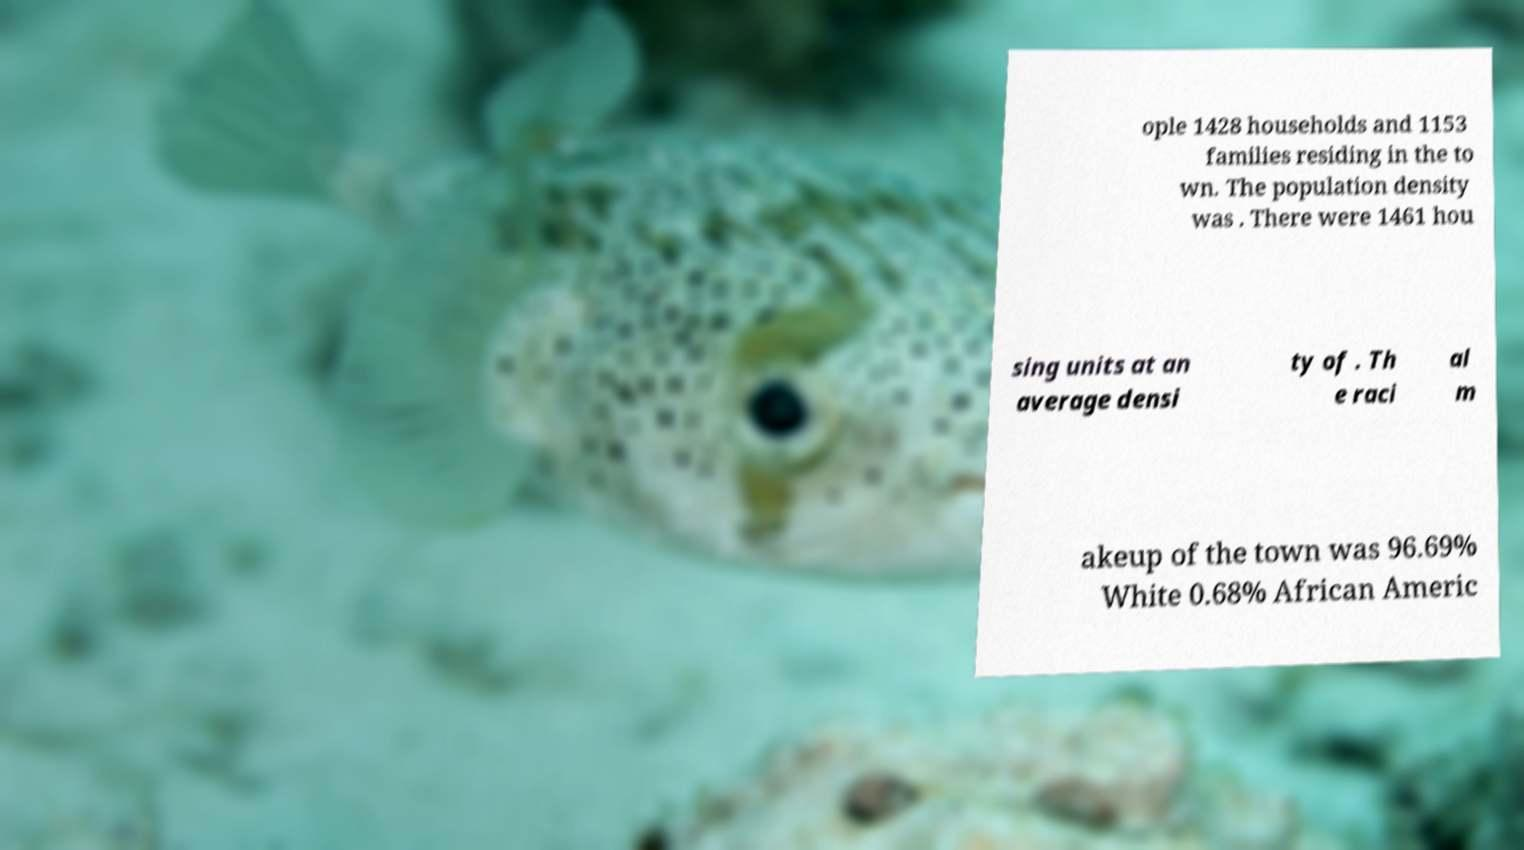For documentation purposes, I need the text within this image transcribed. Could you provide that? ople 1428 households and 1153 families residing in the to wn. The population density was . There were 1461 hou sing units at an average densi ty of . Th e raci al m akeup of the town was 96.69% White 0.68% African Americ 